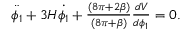<formula> <loc_0><loc_0><loc_500><loc_500>\begin{array} { r } { \ddot { \phi _ { 1 } } + 3 H \dot { \phi _ { 1 } } + \frac { ( 8 \pi + 2 \beta ) } { ( 8 \pi + \beta ) } \frac { d V } { d \phi _ { 1 } } = 0 . } \end{array}</formula> 